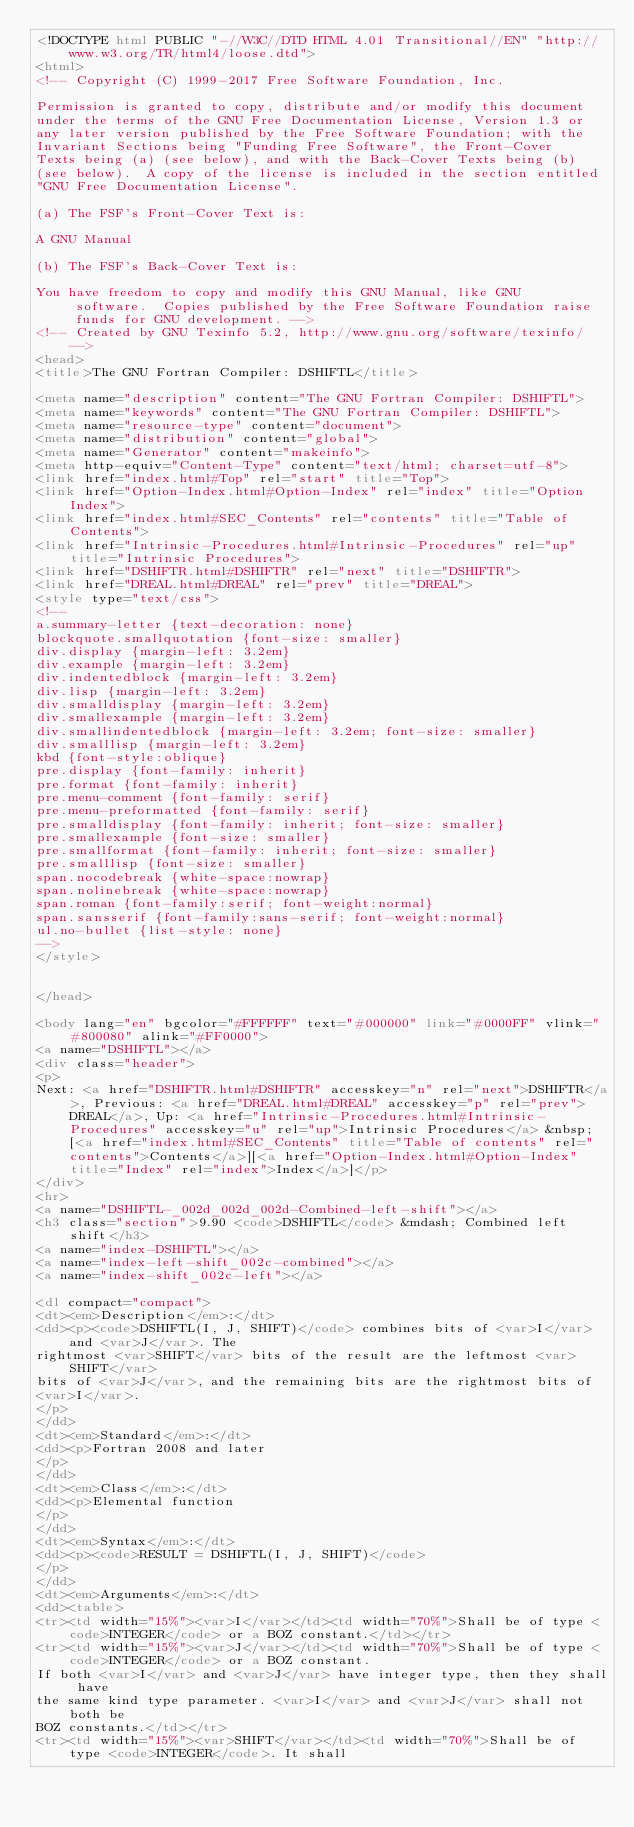<code> <loc_0><loc_0><loc_500><loc_500><_HTML_><!DOCTYPE html PUBLIC "-//W3C//DTD HTML 4.01 Transitional//EN" "http://www.w3.org/TR/html4/loose.dtd">
<html>
<!-- Copyright (C) 1999-2017 Free Software Foundation, Inc.

Permission is granted to copy, distribute and/or modify this document
under the terms of the GNU Free Documentation License, Version 1.3 or
any later version published by the Free Software Foundation; with the
Invariant Sections being "Funding Free Software", the Front-Cover
Texts being (a) (see below), and with the Back-Cover Texts being (b)
(see below).  A copy of the license is included in the section entitled
"GNU Free Documentation License".

(a) The FSF's Front-Cover Text is:

A GNU Manual

(b) The FSF's Back-Cover Text is:

You have freedom to copy and modify this GNU Manual, like GNU
     software.  Copies published by the Free Software Foundation raise
     funds for GNU development. -->
<!-- Created by GNU Texinfo 5.2, http://www.gnu.org/software/texinfo/ -->
<head>
<title>The GNU Fortran Compiler: DSHIFTL</title>

<meta name="description" content="The GNU Fortran Compiler: DSHIFTL">
<meta name="keywords" content="The GNU Fortran Compiler: DSHIFTL">
<meta name="resource-type" content="document">
<meta name="distribution" content="global">
<meta name="Generator" content="makeinfo">
<meta http-equiv="Content-Type" content="text/html; charset=utf-8">
<link href="index.html#Top" rel="start" title="Top">
<link href="Option-Index.html#Option-Index" rel="index" title="Option Index">
<link href="index.html#SEC_Contents" rel="contents" title="Table of Contents">
<link href="Intrinsic-Procedures.html#Intrinsic-Procedures" rel="up" title="Intrinsic Procedures">
<link href="DSHIFTR.html#DSHIFTR" rel="next" title="DSHIFTR">
<link href="DREAL.html#DREAL" rel="prev" title="DREAL">
<style type="text/css">
<!--
a.summary-letter {text-decoration: none}
blockquote.smallquotation {font-size: smaller}
div.display {margin-left: 3.2em}
div.example {margin-left: 3.2em}
div.indentedblock {margin-left: 3.2em}
div.lisp {margin-left: 3.2em}
div.smalldisplay {margin-left: 3.2em}
div.smallexample {margin-left: 3.2em}
div.smallindentedblock {margin-left: 3.2em; font-size: smaller}
div.smalllisp {margin-left: 3.2em}
kbd {font-style:oblique}
pre.display {font-family: inherit}
pre.format {font-family: inherit}
pre.menu-comment {font-family: serif}
pre.menu-preformatted {font-family: serif}
pre.smalldisplay {font-family: inherit; font-size: smaller}
pre.smallexample {font-size: smaller}
pre.smallformat {font-family: inherit; font-size: smaller}
pre.smalllisp {font-size: smaller}
span.nocodebreak {white-space:nowrap}
span.nolinebreak {white-space:nowrap}
span.roman {font-family:serif; font-weight:normal}
span.sansserif {font-family:sans-serif; font-weight:normal}
ul.no-bullet {list-style: none}
-->
</style>


</head>

<body lang="en" bgcolor="#FFFFFF" text="#000000" link="#0000FF" vlink="#800080" alink="#FF0000">
<a name="DSHIFTL"></a>
<div class="header">
<p>
Next: <a href="DSHIFTR.html#DSHIFTR" accesskey="n" rel="next">DSHIFTR</a>, Previous: <a href="DREAL.html#DREAL" accesskey="p" rel="prev">DREAL</a>, Up: <a href="Intrinsic-Procedures.html#Intrinsic-Procedures" accesskey="u" rel="up">Intrinsic Procedures</a> &nbsp; [<a href="index.html#SEC_Contents" title="Table of contents" rel="contents">Contents</a>][<a href="Option-Index.html#Option-Index" title="Index" rel="index">Index</a>]</p>
</div>
<hr>
<a name="DSHIFTL-_002d_002d_002d-Combined-left-shift"></a>
<h3 class="section">9.90 <code>DSHIFTL</code> &mdash; Combined left shift</h3>
<a name="index-DSHIFTL"></a>
<a name="index-left-shift_002c-combined"></a>
<a name="index-shift_002c-left"></a>

<dl compact="compact">
<dt><em>Description</em>:</dt>
<dd><p><code>DSHIFTL(I, J, SHIFT)</code> combines bits of <var>I</var> and <var>J</var>. The
rightmost <var>SHIFT</var> bits of the result are the leftmost <var>SHIFT</var>
bits of <var>J</var>, and the remaining bits are the rightmost bits of
<var>I</var>.
</p>
</dd>
<dt><em>Standard</em>:</dt>
<dd><p>Fortran 2008 and later
</p>
</dd>
<dt><em>Class</em>:</dt>
<dd><p>Elemental function
</p>
</dd>
<dt><em>Syntax</em>:</dt>
<dd><p><code>RESULT = DSHIFTL(I, J, SHIFT)</code>
</p>
</dd>
<dt><em>Arguments</em>:</dt>
<dd><table>
<tr><td width="15%"><var>I</var></td><td width="70%">Shall be of type <code>INTEGER</code> or a BOZ constant.</td></tr>
<tr><td width="15%"><var>J</var></td><td width="70%">Shall be of type <code>INTEGER</code> or a BOZ constant.
If both <var>I</var> and <var>J</var> have integer type, then they shall have
the same kind type parameter. <var>I</var> and <var>J</var> shall not both be
BOZ constants.</td></tr>
<tr><td width="15%"><var>SHIFT</var></td><td width="70%">Shall be of type <code>INTEGER</code>. It shall</code> 